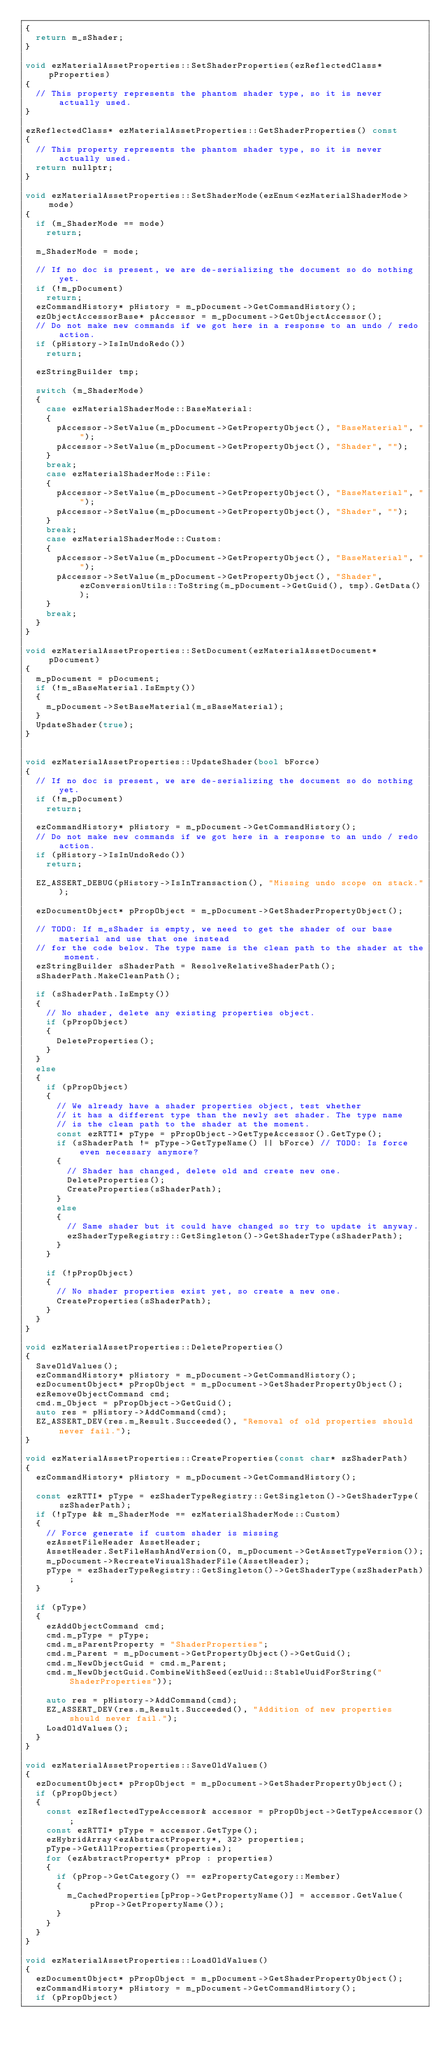<code> <loc_0><loc_0><loc_500><loc_500><_C++_>{
  return m_sShader;
}

void ezMaterialAssetProperties::SetShaderProperties(ezReflectedClass* pProperties)
{
  // This property represents the phantom shader type, so it is never actually used.
}

ezReflectedClass* ezMaterialAssetProperties::GetShaderProperties() const
{
  // This property represents the phantom shader type, so it is never actually used.
  return nullptr;
}

void ezMaterialAssetProperties::SetShaderMode(ezEnum<ezMaterialShaderMode> mode)
{
  if (m_ShaderMode == mode)
    return;

  m_ShaderMode = mode;

  // If no doc is present, we are de-serializing the document so do nothing yet.
  if (!m_pDocument)
    return;
  ezCommandHistory* pHistory = m_pDocument->GetCommandHistory();
  ezObjectAccessorBase* pAccessor = m_pDocument->GetObjectAccessor();
  // Do not make new commands if we got here in a response to an undo / redo action.
  if (pHistory->IsInUndoRedo())
    return;

  ezStringBuilder tmp;

  switch (m_ShaderMode)
  {
    case ezMaterialShaderMode::BaseMaterial:
    {
      pAccessor->SetValue(m_pDocument->GetPropertyObject(), "BaseMaterial", "");
      pAccessor->SetValue(m_pDocument->GetPropertyObject(), "Shader", "");
    }
    break;
    case ezMaterialShaderMode::File:
    {
      pAccessor->SetValue(m_pDocument->GetPropertyObject(), "BaseMaterial", "");
      pAccessor->SetValue(m_pDocument->GetPropertyObject(), "Shader", "");
    }
    break;
    case ezMaterialShaderMode::Custom:
    {
      pAccessor->SetValue(m_pDocument->GetPropertyObject(), "BaseMaterial", "");
      pAccessor->SetValue(m_pDocument->GetPropertyObject(), "Shader", ezConversionUtils::ToString(m_pDocument->GetGuid(), tmp).GetData());
    }
    break;
  }
}

void ezMaterialAssetProperties::SetDocument(ezMaterialAssetDocument* pDocument)
{
  m_pDocument = pDocument;
  if (!m_sBaseMaterial.IsEmpty())
  {
    m_pDocument->SetBaseMaterial(m_sBaseMaterial);
  }
  UpdateShader(true);
}


void ezMaterialAssetProperties::UpdateShader(bool bForce)
{
  // If no doc is present, we are de-serializing the document so do nothing yet.
  if (!m_pDocument)
    return;

  ezCommandHistory* pHistory = m_pDocument->GetCommandHistory();
  // Do not make new commands if we got here in a response to an undo / redo action.
  if (pHistory->IsInUndoRedo())
    return;

  EZ_ASSERT_DEBUG(pHistory->IsInTransaction(), "Missing undo scope on stack.");

  ezDocumentObject* pPropObject = m_pDocument->GetShaderPropertyObject();

  // TODO: If m_sShader is empty, we need to get the shader of our base material and use that one instead
  // for the code below. The type name is the clean path to the shader at the moment.
  ezStringBuilder sShaderPath = ResolveRelativeShaderPath();
  sShaderPath.MakeCleanPath();

  if (sShaderPath.IsEmpty())
  {
    // No shader, delete any existing properties object.
    if (pPropObject)
    {
      DeleteProperties();
    }
  }
  else
  {
    if (pPropObject)
    {
      // We already have a shader properties object, test whether
      // it has a different type than the newly set shader. The type name
      // is the clean path to the shader at the moment.
      const ezRTTI* pType = pPropObject->GetTypeAccessor().GetType();
      if (sShaderPath != pType->GetTypeName() || bForce) // TODO: Is force even necessary anymore?
      {
        // Shader has changed, delete old and create new one.
        DeleteProperties();
        CreateProperties(sShaderPath);
      }
      else
      {
        // Same shader but it could have changed so try to update it anyway.
        ezShaderTypeRegistry::GetSingleton()->GetShaderType(sShaderPath);
      }
    }

    if (!pPropObject)
    {
      // No shader properties exist yet, so create a new one.
      CreateProperties(sShaderPath);
    }
  }
}

void ezMaterialAssetProperties::DeleteProperties()
{
  SaveOldValues();
  ezCommandHistory* pHistory = m_pDocument->GetCommandHistory();
  ezDocumentObject* pPropObject = m_pDocument->GetShaderPropertyObject();
  ezRemoveObjectCommand cmd;
  cmd.m_Object = pPropObject->GetGuid();
  auto res = pHistory->AddCommand(cmd);
  EZ_ASSERT_DEV(res.m_Result.Succeeded(), "Removal of old properties should never fail.");
}

void ezMaterialAssetProperties::CreateProperties(const char* szShaderPath)
{
  ezCommandHistory* pHistory = m_pDocument->GetCommandHistory();

  const ezRTTI* pType = ezShaderTypeRegistry::GetSingleton()->GetShaderType(szShaderPath);
  if (!pType && m_ShaderMode == ezMaterialShaderMode::Custom)
  {
    // Force generate if custom shader is missing
    ezAssetFileHeader AssetHeader;
    AssetHeader.SetFileHashAndVersion(0, m_pDocument->GetAssetTypeVersion());
    m_pDocument->RecreateVisualShaderFile(AssetHeader);
    pType = ezShaderTypeRegistry::GetSingleton()->GetShaderType(szShaderPath);
  }

  if (pType)
  {
    ezAddObjectCommand cmd;
    cmd.m_pType = pType;
    cmd.m_sParentProperty = "ShaderProperties";
    cmd.m_Parent = m_pDocument->GetPropertyObject()->GetGuid();
    cmd.m_NewObjectGuid = cmd.m_Parent;
    cmd.m_NewObjectGuid.CombineWithSeed(ezUuid::StableUuidForString("ShaderProperties"));

    auto res = pHistory->AddCommand(cmd);
    EZ_ASSERT_DEV(res.m_Result.Succeeded(), "Addition of new properties should never fail.");
    LoadOldValues();
  }
}

void ezMaterialAssetProperties::SaveOldValues()
{
  ezDocumentObject* pPropObject = m_pDocument->GetShaderPropertyObject();
  if (pPropObject)
  {
    const ezIReflectedTypeAccessor& accessor = pPropObject->GetTypeAccessor();
    const ezRTTI* pType = accessor.GetType();
    ezHybridArray<ezAbstractProperty*, 32> properties;
    pType->GetAllProperties(properties);
    for (ezAbstractProperty* pProp : properties)
    {
      if (pProp->GetCategory() == ezPropertyCategory::Member)
      {
        m_CachedProperties[pProp->GetPropertyName()] = accessor.GetValue(pProp->GetPropertyName());
      }
    }
  }
}

void ezMaterialAssetProperties::LoadOldValues()
{
  ezDocumentObject* pPropObject = m_pDocument->GetShaderPropertyObject();
  ezCommandHistory* pHistory = m_pDocument->GetCommandHistory();
  if (pPropObject)</code> 